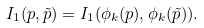<formula> <loc_0><loc_0><loc_500><loc_500>I _ { 1 } ( p , \tilde { p } ) = I _ { 1 } ( \phi _ { k } ( p ) , \phi _ { k } ( \tilde { p } ) ) .</formula> 